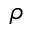<formula> <loc_0><loc_0><loc_500><loc_500>\rho</formula> 